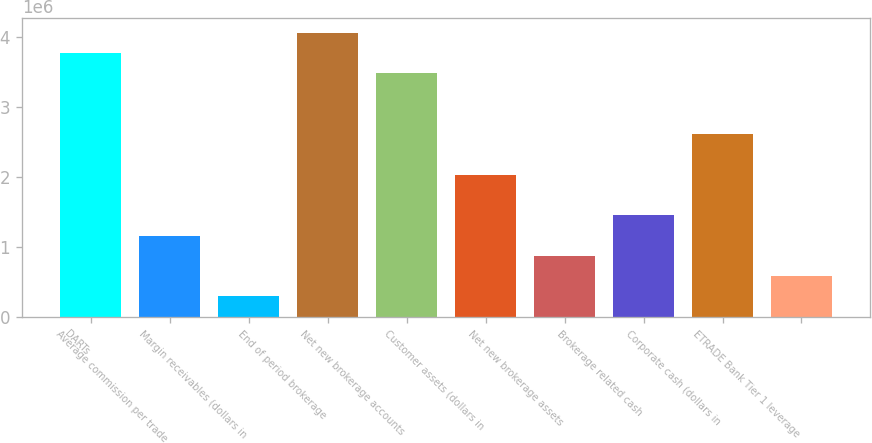Convert chart. <chart><loc_0><loc_0><loc_500><loc_500><bar_chart><fcel>DARTs<fcel>Average commission per trade<fcel>Margin receivables (dollars in<fcel>End of period brokerage<fcel>Net new brokerage accounts<fcel>Customer assets (dollars in<fcel>Net new brokerage assets<fcel>Brokerage related cash<fcel>Corporate cash (dollars in<fcel>ETRADE Bank Tier 1 leverage<nl><fcel>3.77415e+06<fcel>1.16128e+06<fcel>290321<fcel>4.06447e+06<fcel>3.48383e+06<fcel>2.03223e+06<fcel>870959<fcel>1.4516e+06<fcel>2.61287e+06<fcel>580640<nl></chart> 